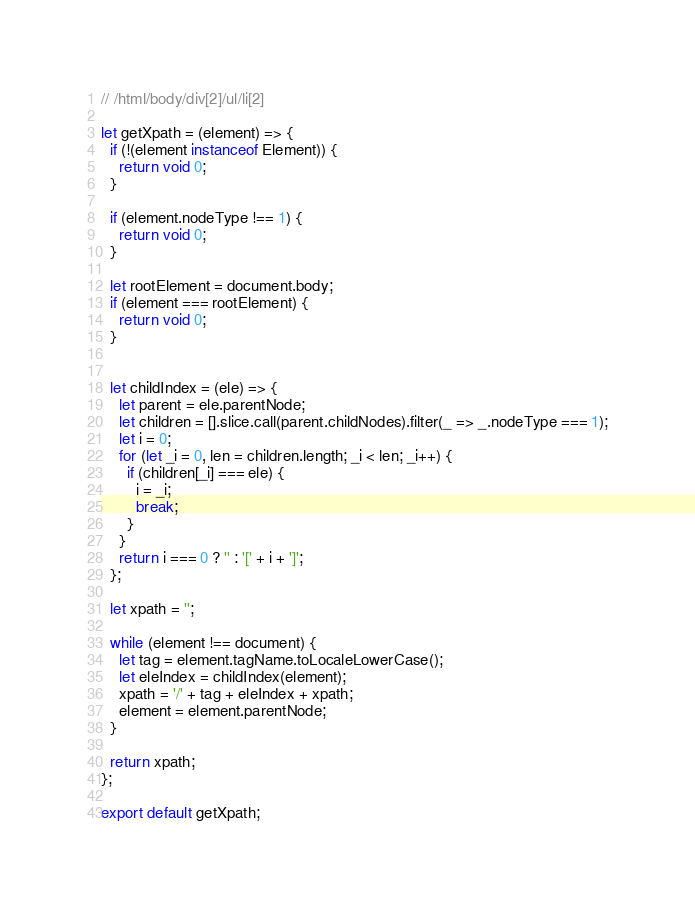Convert code to text. <code><loc_0><loc_0><loc_500><loc_500><_JavaScript_>// /html/body/div[2]/ul/li[2]

let getXpath = (element) => {
  if (!(element instanceof Element)) {
    return void 0;
  }

  if (element.nodeType !== 1) {
    return void 0;
  }

  let rootElement = document.body;
  if (element === rootElement) {
    return void 0;
  }


  let childIndex = (ele) => {
    let parent = ele.parentNode;
    let children = [].slice.call(parent.childNodes).filter(_ => _.nodeType === 1);
    let i = 0;
    for (let _i = 0, len = children.length; _i < len; _i++) {
      if (children[_i] === ele) {
        i = _i;
        break;
      }
    }
    return i === 0 ? '' : '[' + i + ']';
  };

  let xpath = '';

  while (element !== document) {
    let tag = element.tagName.toLocaleLowerCase();
    let eleIndex = childIndex(element);
    xpath = '/' + tag + eleIndex + xpath;
    element = element.parentNode;
  }

  return xpath;
};

export default getXpath;
</code> 